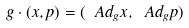Convert formula to latex. <formula><loc_0><loc_0><loc_500><loc_500>g \cdot ( x , p ) = ( \ A d _ { g } x , \ A d _ { g } p )</formula> 